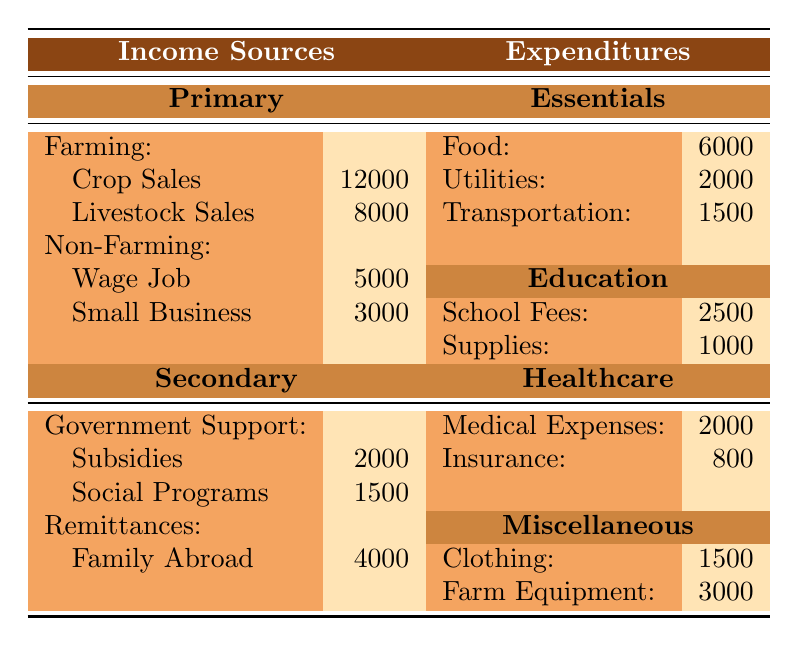What is the total income from farming? The income from farming comes from crop sales and livestock sales. Adding these two values gives us 12000 (crop sales) + 8000 (livestock sales) = 20000.
Answer: 20000 What is the total expenditure on essentials? The total expenditure on essentials includes food, utilities, and transportation. Summing these amounts gives us 6000 (food) + 2000 (utilities) + 1500 (transportation) = 9500.
Answer: 9500 Are remittances from family abroad listed as a primary income source? Remittances are categorized as a secondary source of income, not a primary source.
Answer: No What is the expenditure on education compared to healthcare? The total education expenditure is the sum of school fees and supplies: 2500 + 1000 = 3500. The total healthcare expenditure sums medical expenses and insurance: 2000 + 800 = 2800. Since 3500 (education) is greater than 2800 (healthcare), education expenditure is higher.
Answer: Education expenditure is higher What is the total income from non-farming sources? The non-farming income includes wage job and small business income. Adding these two amounts gives us 5000 (wage) + 3000 (small business) = 8000.
Answer: 8000 What percentage of total income comes from government support? The total income is the sum of all primary and secondary income sources: 20000 (farming) + 8000 (non-farming) + 3500 (government support) + 4000 (remittances) =  33500. The government support amounts to 3500. The percentage of total income from government support is (3500 / 33500) * 100 ≈ 10.45%.
Answer: Approximately 10.45% What is the total expenditure on miscellaneous items? The total miscellaneous expenditure includes clothing and farm equipment: 1500 (clothing) + 3000 (farm equipment) = 4500.
Answer: 4500 If you were to cut down transportation expenses by half, what would the new total expenditure be? The current transportation expenditure is 1500. Halving it gives us 1500 / 2 = 750. Then, the new total would be the original total (9500) minus the original transportation expense plus the reduced expense: 9500 - 1500 + 750 = 8750.
Answer: 8750 Is the total income from remittances more than the total spent on essentials? The total from remittances is 4000, while the total spent on essentials is 9500. Since 4000 is less than 9500, the answer is no.
Answer: No What is the difference between total income from farming and total essentials expenditure? The total income from farming is 20000, and the total essentials expenditure is 9500. The difference is 20000 - 9500 = 10500.
Answer: 10500 